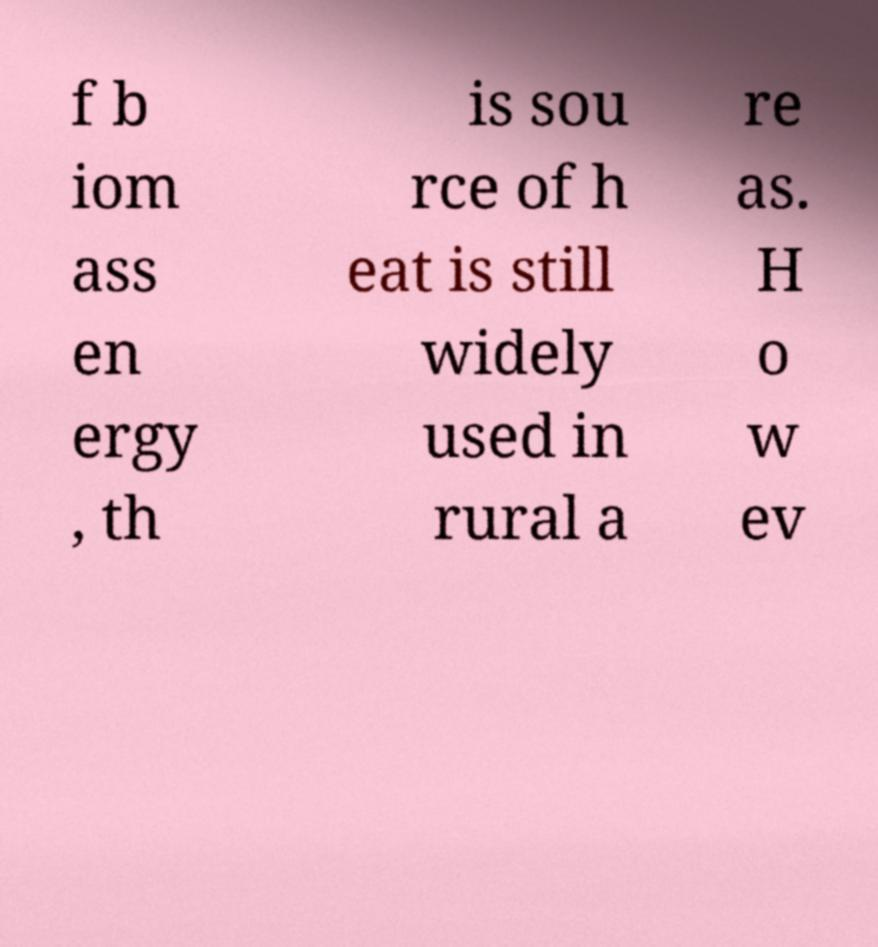What messages or text are displayed in this image? I need them in a readable, typed format. f b iom ass en ergy , th is sou rce of h eat is still widely used in rural a re as. H o w ev 